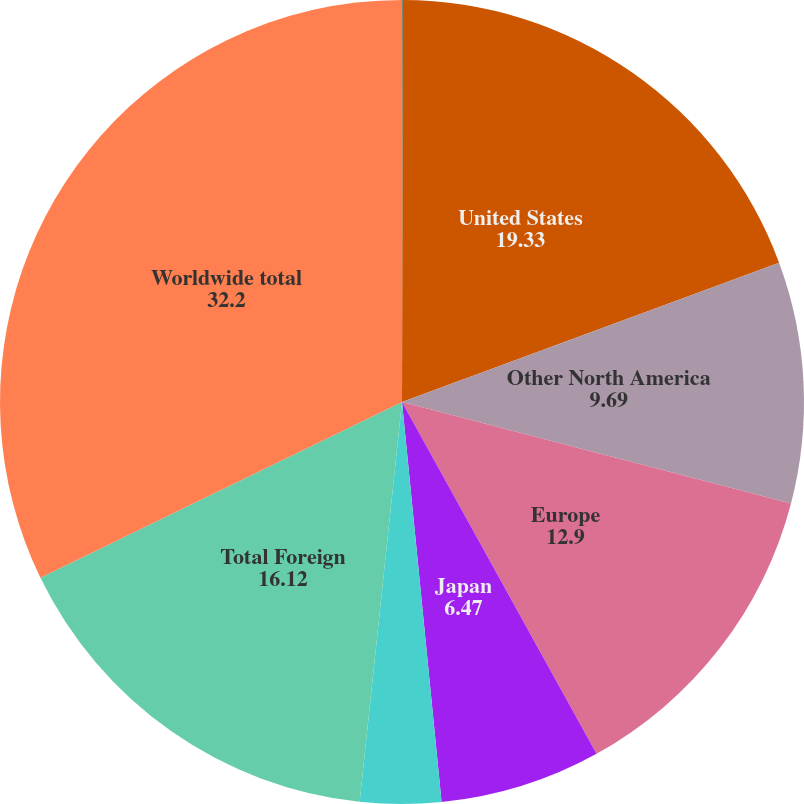Convert chart. <chart><loc_0><loc_0><loc_500><loc_500><pie_chart><fcel>(In thousands)<fcel>United States<fcel>Other North America<fcel>Europe<fcel>Japan<fcel>Asia Pacific/Rest of World<fcel>Total Foreign<fcel>Worldwide total<nl><fcel>0.04%<fcel>19.33%<fcel>9.69%<fcel>12.9%<fcel>6.47%<fcel>3.25%<fcel>16.12%<fcel>32.2%<nl></chart> 